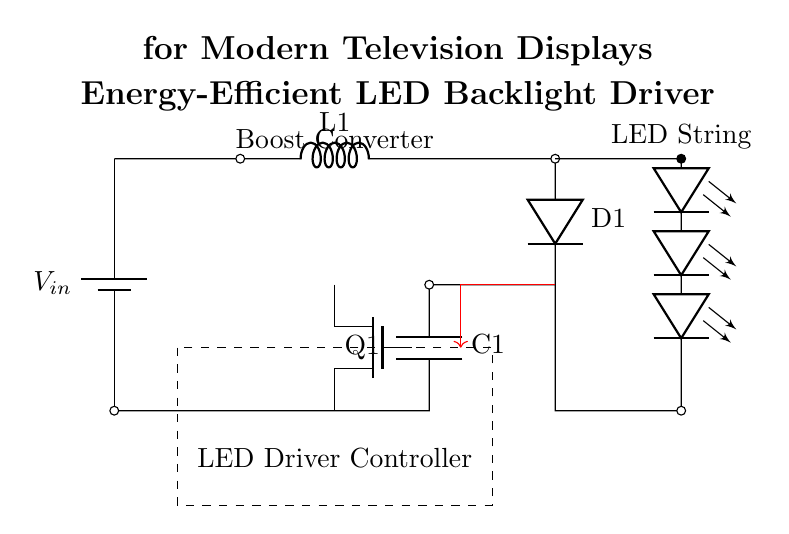What is the primary function of the boost converter in this circuit? The boost converter is used to step up the input voltage to a higher level suitable for driving the LED string, ensuring that adequate voltage is supplied for proper operation.
Answer: Step-up What component is used to control the LED driver? The circuit diagram indicates the presence of a "LED Driver Controller," which manages the operation of the LED driver, providing necessary feedback and control signals to optimize performance.
Answer: LED Driver Controller How many LED modules are connected in series? Observing the circuit, there are four LED modules (leDo) connected in series, as illustrated by the line connecting these components sequentially.
Answer: Four What is the role of the MOSFET labeled Q1 in this circuit? The MOSFET, labeled Q1, serves as a switch in the driver circuit, controlling the flow of current to the LED string based on the driver controller's signals, thereby regulating brightness and efficiency.
Answer: Switch What type of capacitors and inductors are used in this circuit? The circuit diagram shows the use of a capacitor labeled C1 and an inductor labeled L1, both of which are essential components for energy storage and smoothing in the boost converter operation.
Answer: Capacitor and Inductor What is the function of the feedback loop indicated by the red arrow in the circuit? The feedback loop provides real-time information to the LED Driver Controller about the output, allowing it to adjust the performance of the boost converter and maintain consistent brightness of the LEDs under varying conditions.
Answer: Control feedback What is the power source voltage labeled as V_in? The voltage is labeled as V_in on the circuit diagram, though the exact numerical value isn't provided, it typically represents the input voltage supplied to the boost converter, which can vary based on the application.
Answer: V_in 